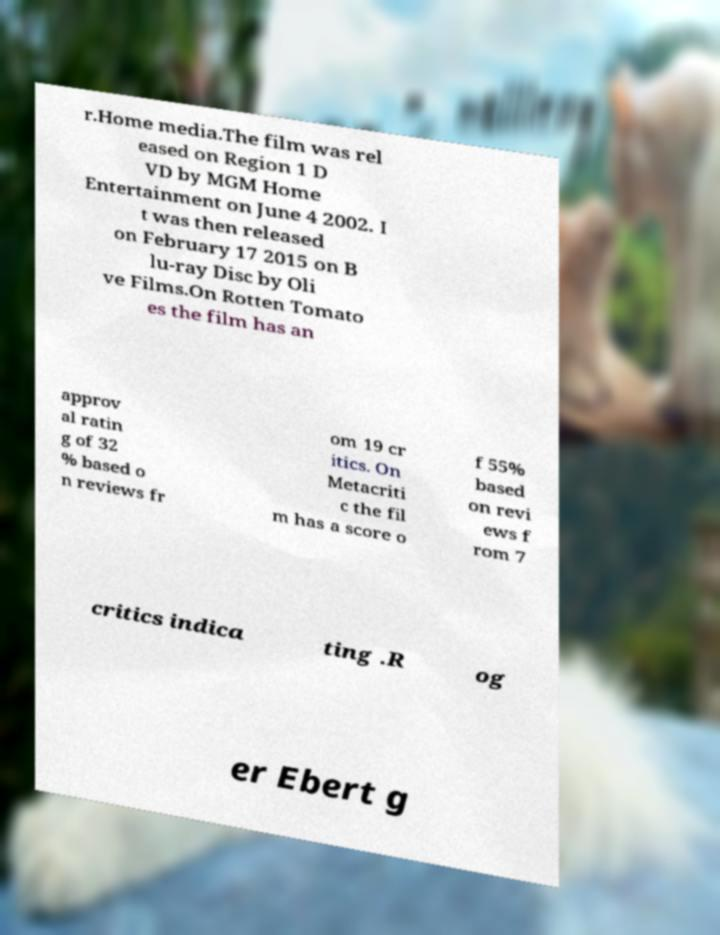For documentation purposes, I need the text within this image transcribed. Could you provide that? r.Home media.The film was rel eased on Region 1 D VD by MGM Home Entertainment on June 4 2002. I t was then released on February 17 2015 on B lu-ray Disc by Oli ve Films.On Rotten Tomato es the film has an approv al ratin g of 32 % based o n reviews fr om 19 cr itics. On Metacriti c the fil m has a score o f 55% based on revi ews f rom 7 critics indica ting .R og er Ebert g 